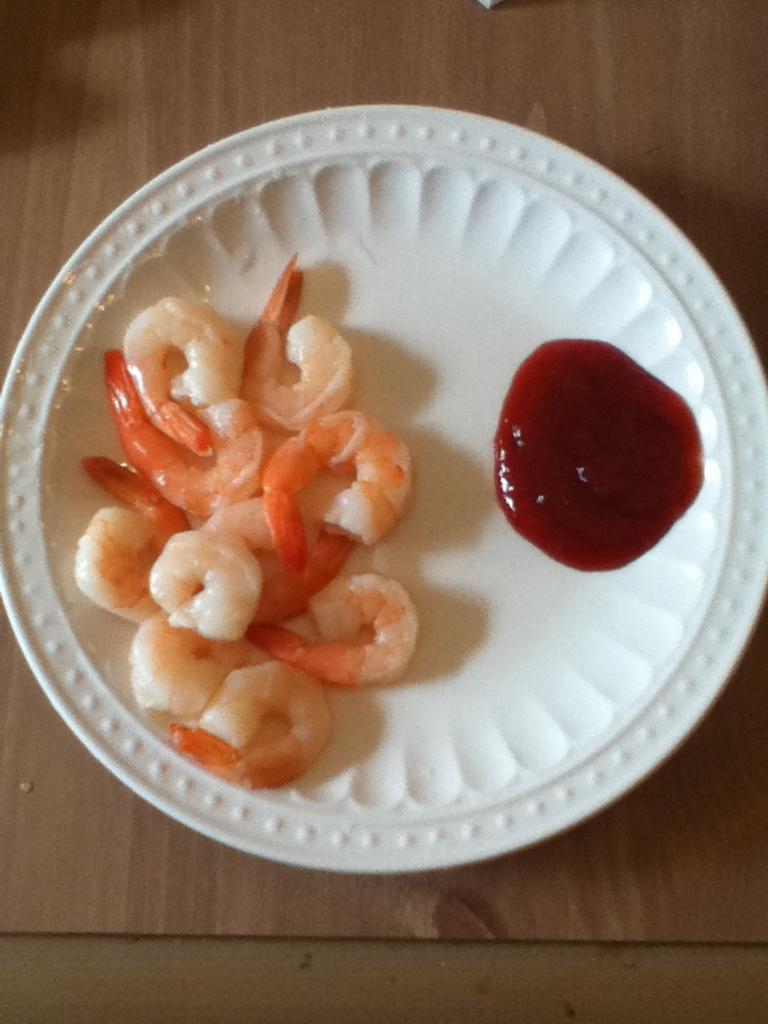How would you summarize this image in a sentence or two? In this image there is a food item placed on a plate. 